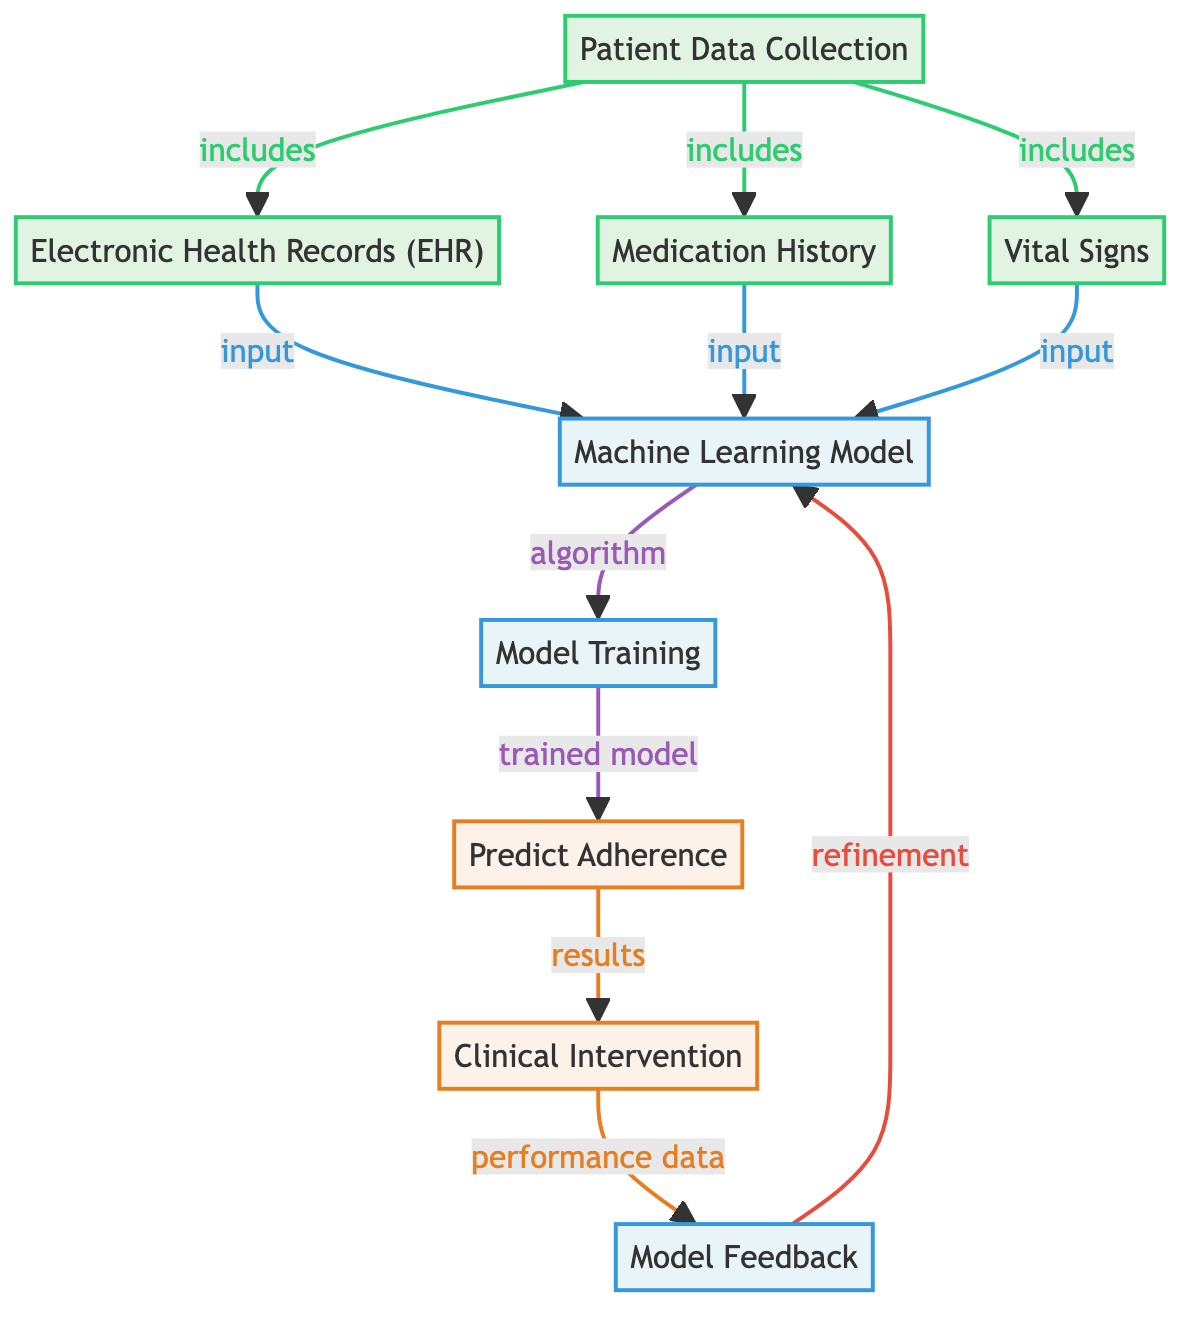What are the three main sources of patient data? The diagram shows three main sources of patient data: Electronic Health Records, Medication History, and Vital Signs, all linked to Patient Data Collection.
Answer: Electronic Health Records, Medication History, Vital Signs What is the output of the Machine Learning Model? The next node after the Machine Learning Model is "Predict Adherence," indicating that the output is focused on predicting how well patients adhere to their medication.
Answer: Predict Adherence How many input nodes are present in the diagram? By counting the nodes labeled as input, we find three: Electronic Health Records, Medication History, and Vital Signs.
Answer: Three What role does the feedback node play in the diagram? The feedback node is connected to the intervention and the Machine Learning Model, showing that it provides performance data that can be used for refinement of the model.
Answer: Refinement What is the order of processing after the Model Training? The diagram indicates that after Model Training, the process moves to the "Predict Adherence" node, meaning predictions are made immediately after training.
Answer: Predict Adherence Which node is classified as an output? The diagram shows multiple nodes as outputs; however, the specific output of interest relevant to prediction is "Predict Adherence."
Answer: Predict Adherence What is the relationship between the intervention and model feedback? The diagram indicates that the Intervention node produces performance data, which is sent to the feedback node for refining the Machine Learning Model.
Answer: Produces performance data What machine learning phase comes after input data collection? Following the collection of input data, the next phase is the Machine Learning Model, where data is processed as input for analysis.
Answer: Machine Learning Model What task follows "Predict Adherence" in the flow? According to the diagram, after the "Predict Adherence" task, the next stage involves "Clinical Intervention," suggesting actions taken based on the predictions made.
Answer: Clinical Intervention 